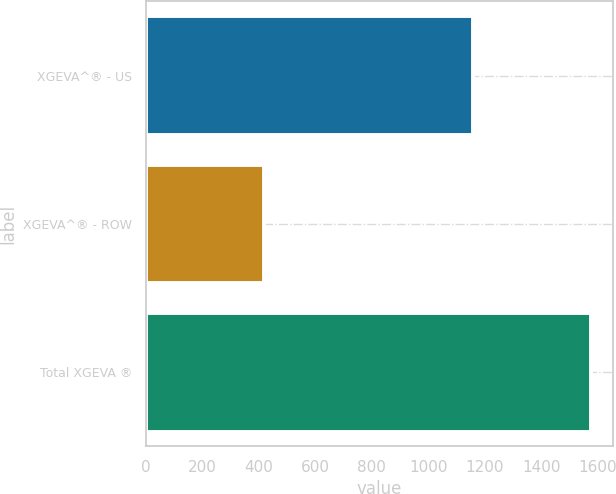Convert chart. <chart><loc_0><loc_0><loc_500><loc_500><bar_chart><fcel>XGEVA^® - US<fcel>XGEVA^® - ROW<fcel>Total XGEVA ®<nl><fcel>1157<fcel>418<fcel>1575<nl></chart> 